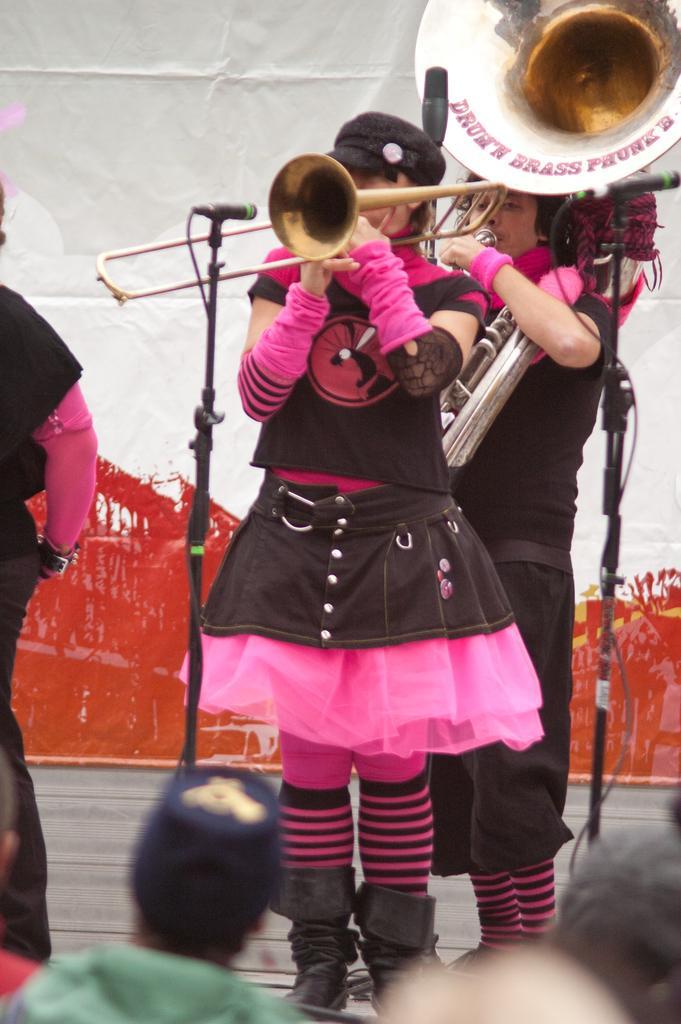Describe this image in one or two sentences. In the foreground of this image, there are two women standing in black and pink dress holding trumpets in their hands. In the background, there is a wall. On the left and bottom of the image, there are persons. 